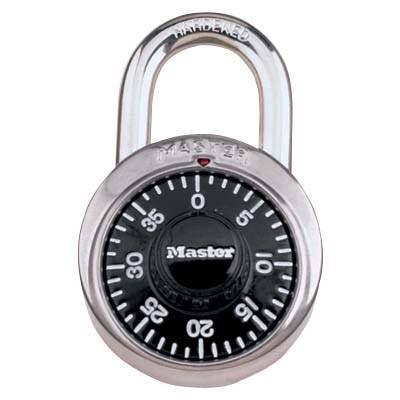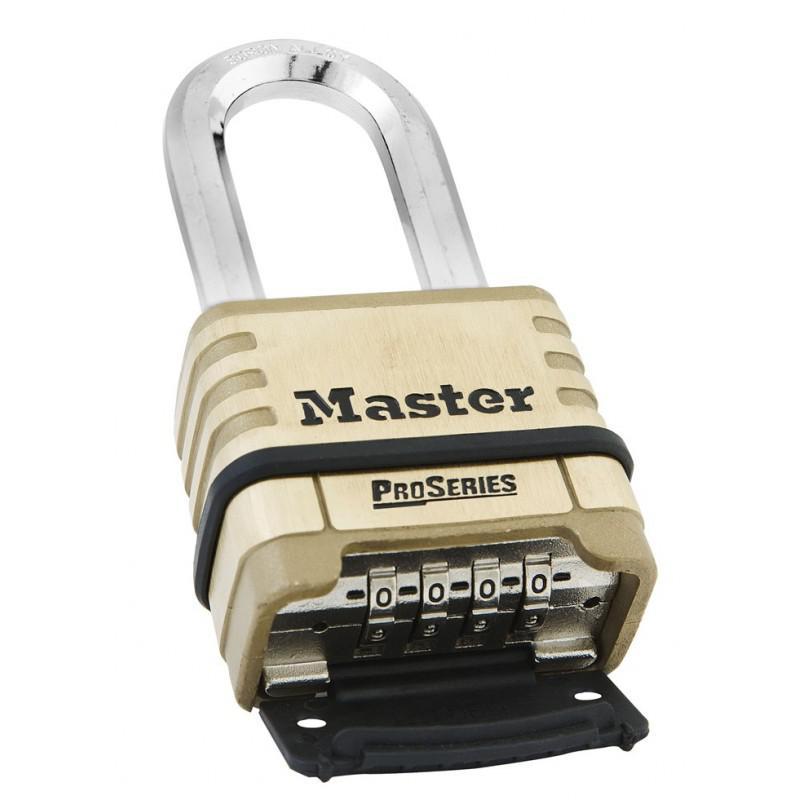The first image is the image on the left, the second image is the image on the right. Analyze the images presented: Is the assertion "Two padlocks each have a different belt combination system and are different colors, but are both locked and have silver locking loops." valid? Answer yes or no. No. The first image is the image on the left, the second image is the image on the right. For the images shown, is this caption "Each lock is rectangular shaped, and one lock contains exactly three rows of numbers on wheels." true? Answer yes or no. No. 